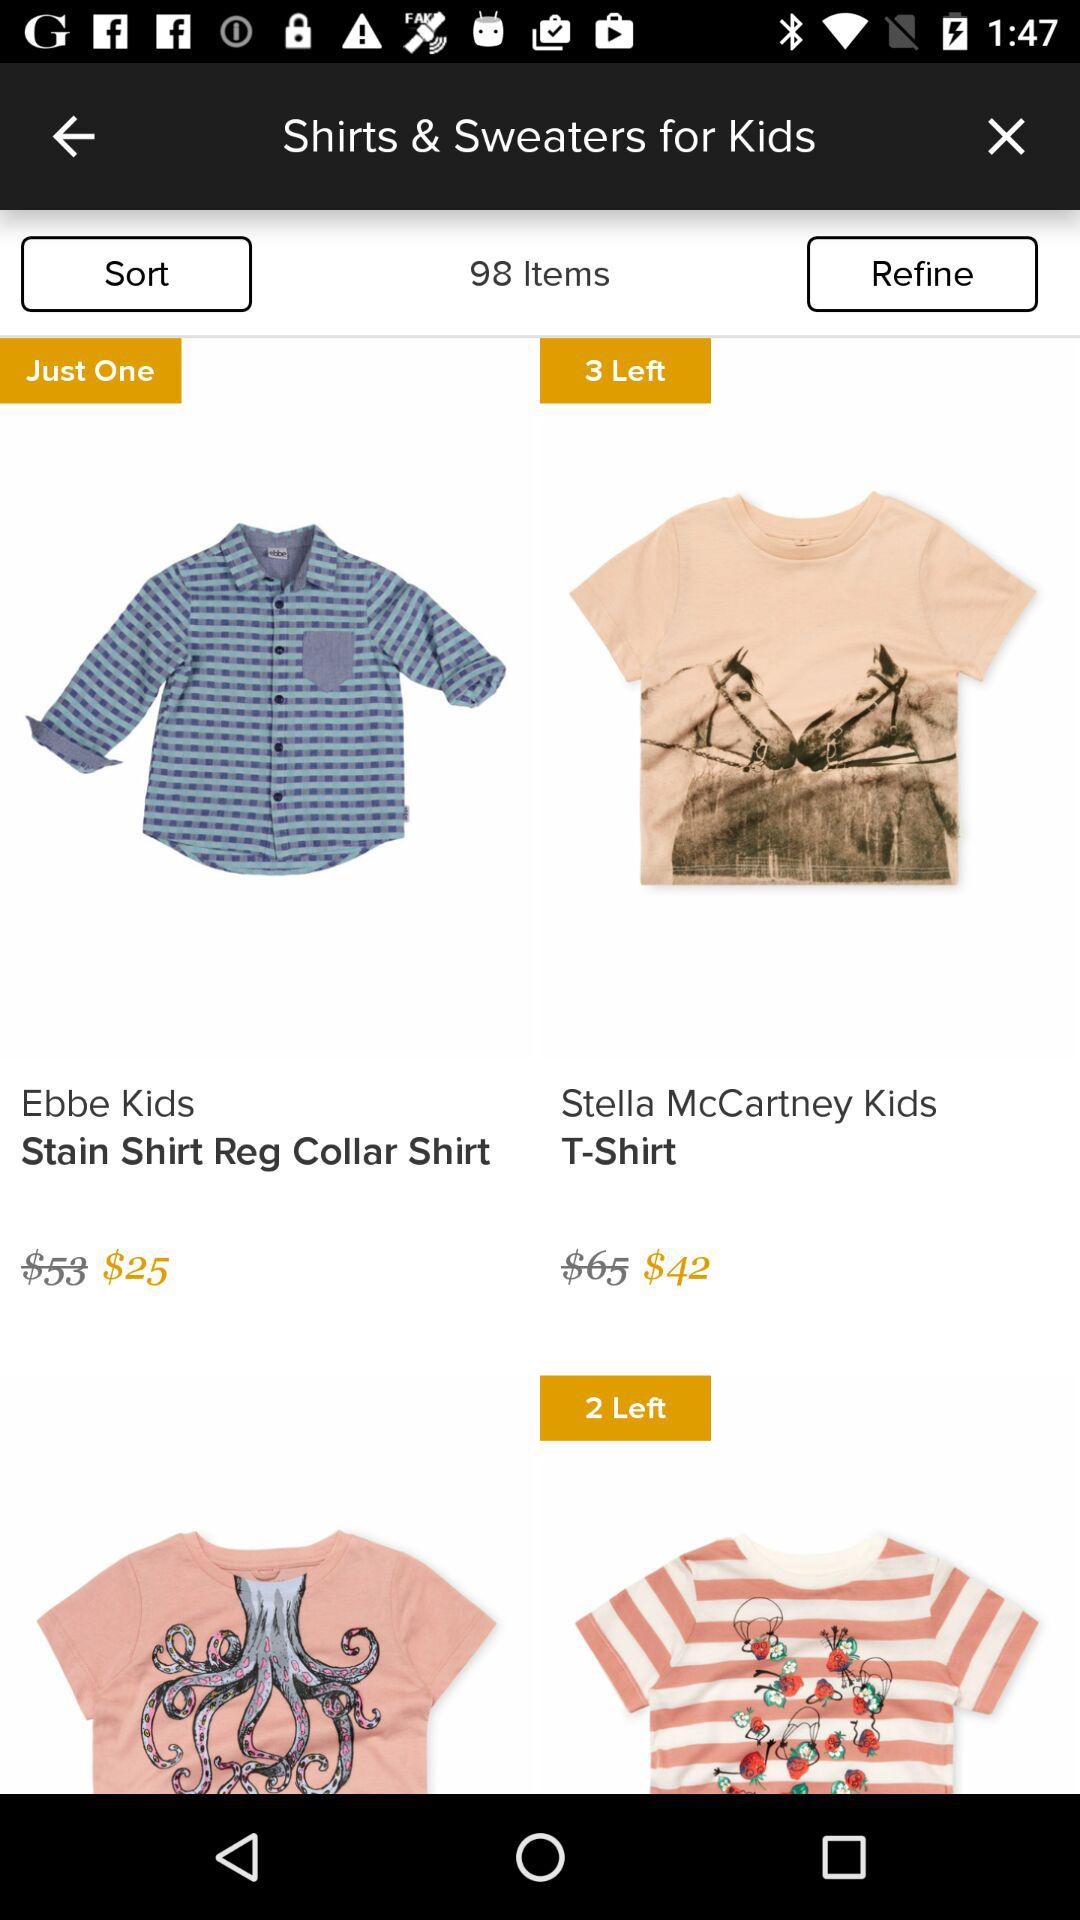How many items are left in "Stella McCartney Kids"? There are three items left. 